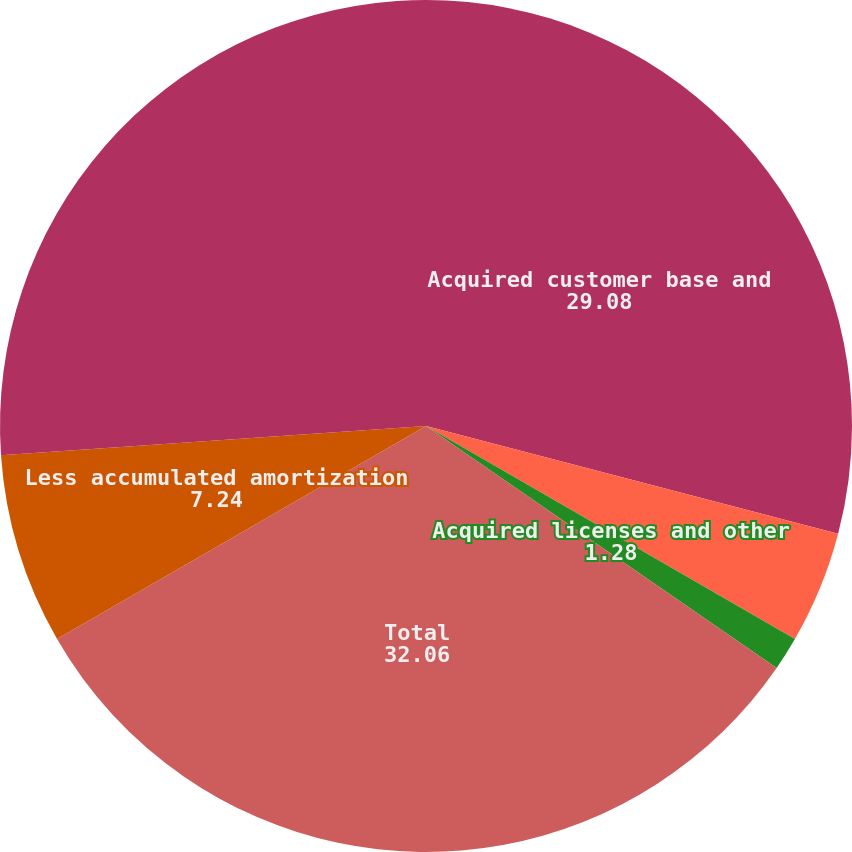Convert chart. <chart><loc_0><loc_0><loc_500><loc_500><pie_chart><fcel>Acquired customer base and<fcel>Deferred financing costs<fcel>Acquired licenses and other<fcel>Total<fcel>Less accumulated amortization<fcel>Other intangible assets net<nl><fcel>29.08%<fcel>4.26%<fcel>1.28%<fcel>32.06%<fcel>7.24%<fcel>26.1%<nl></chart> 